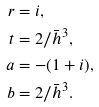Convert formula to latex. <formula><loc_0><loc_0><loc_500><loc_500>r & = i , \\ t & = 2 / \bar { h } ^ { 3 } , \\ a & = - ( 1 + i ) , \\ b & = 2 / \bar { h } ^ { 3 } .</formula> 